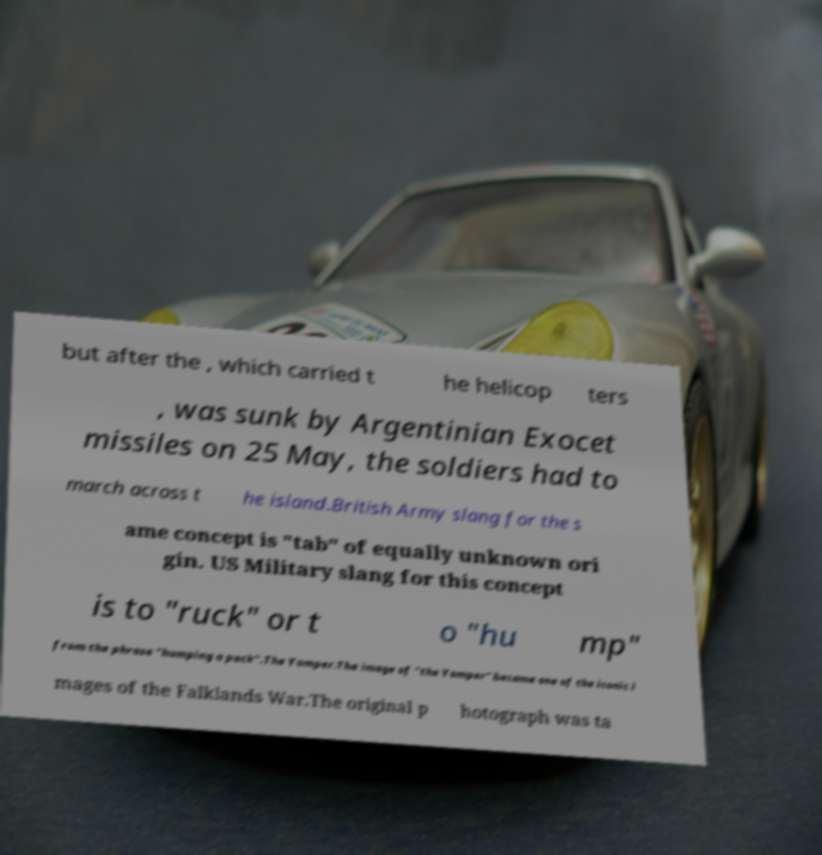Can you accurately transcribe the text from the provided image for me? but after the , which carried t he helicop ters , was sunk by Argentinian Exocet missiles on 25 May, the soldiers had to march across t he island.British Army slang for the s ame concept is "tab" of equally unknown ori gin. US Military slang for this concept is to "ruck" or t o "hu mp" from the phrase "humping a pack".The Yomper.The image of "the Yomper" became one of the iconic i mages of the Falklands War.The original p hotograph was ta 